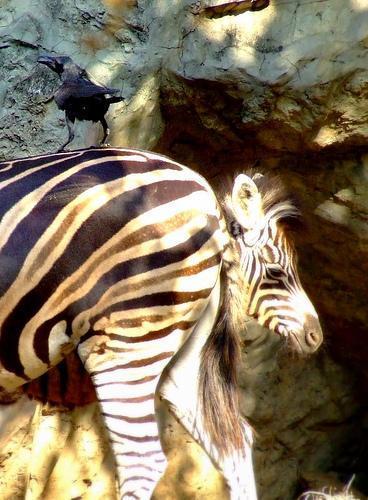How many animals are in the picture?
Give a very brief answer. 3. How many zebras are there?
Give a very brief answer. 2. How many blue buses are there?
Give a very brief answer. 0. 